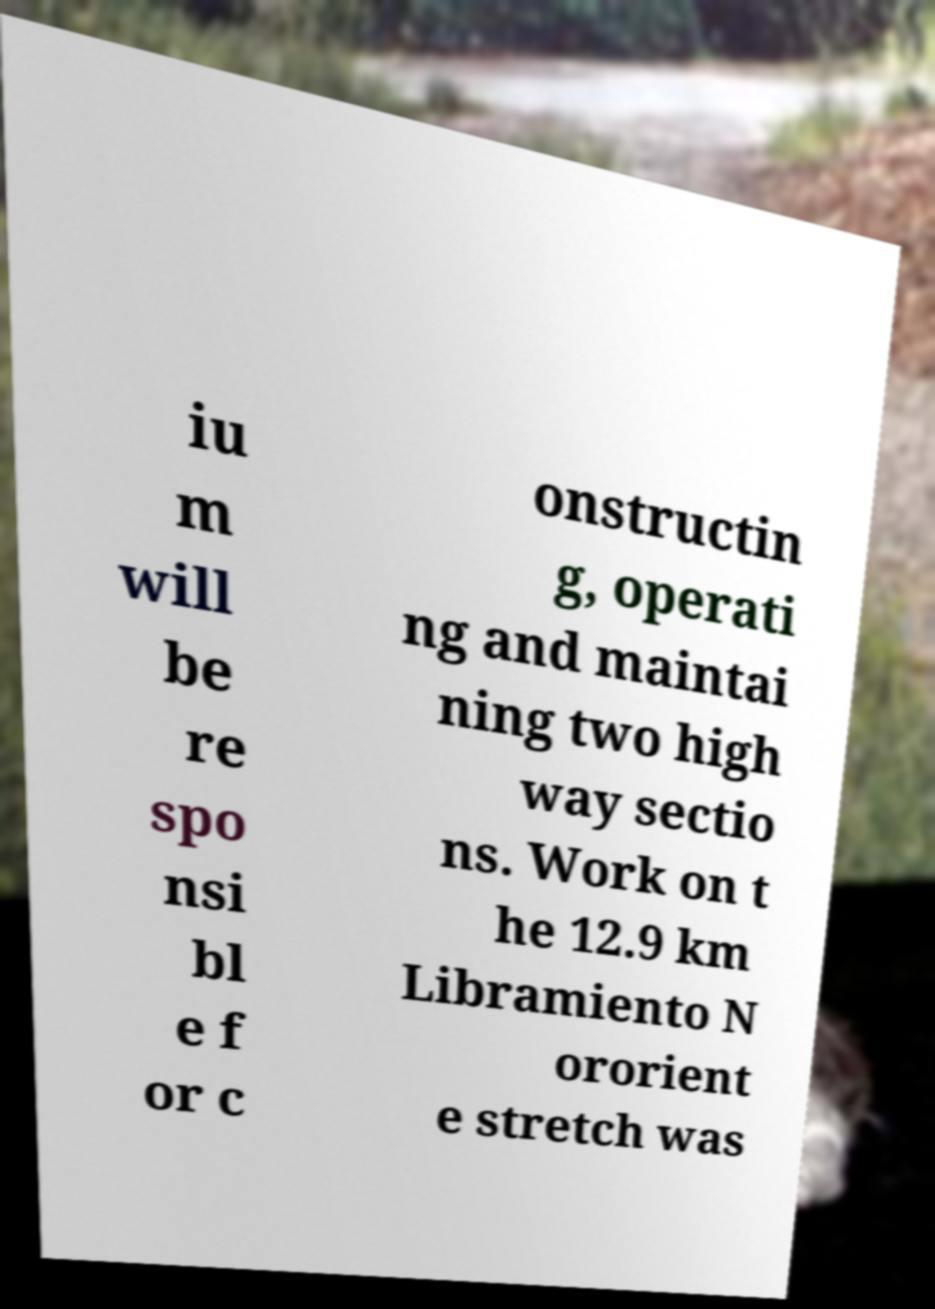Can you read and provide the text displayed in the image?This photo seems to have some interesting text. Can you extract and type it out for me? iu m will be re spo nsi bl e f or c onstructin g, operati ng and maintai ning two high way sectio ns. Work on t he 12.9 km Libramiento N ororient e stretch was 